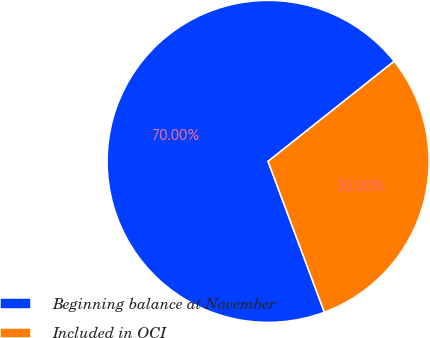Convert chart. <chart><loc_0><loc_0><loc_500><loc_500><pie_chart><fcel>Beginning balance at November<fcel>Included in OCI<nl><fcel>70.0%<fcel>30.0%<nl></chart> 